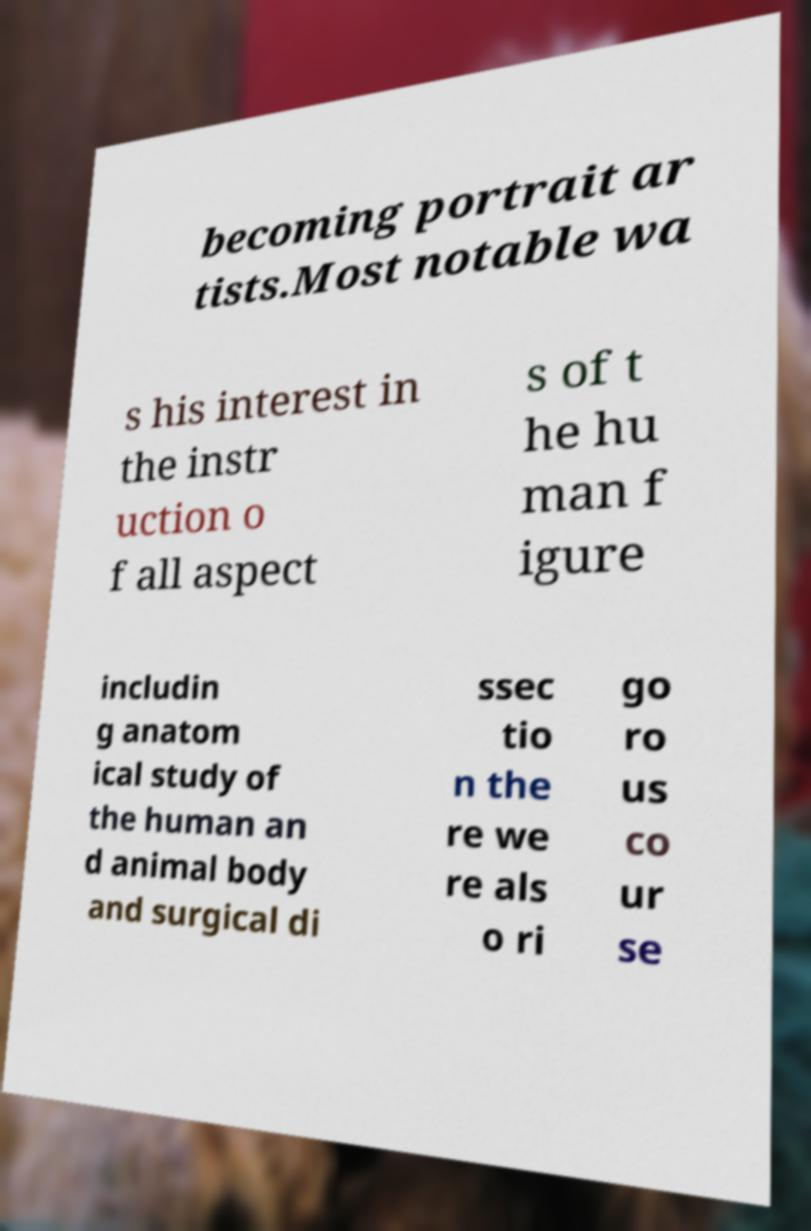Can you accurately transcribe the text from the provided image for me? becoming portrait ar tists.Most notable wa s his interest in the instr uction o f all aspect s of t he hu man f igure includin g anatom ical study of the human an d animal body and surgical di ssec tio n the re we re als o ri go ro us co ur se 